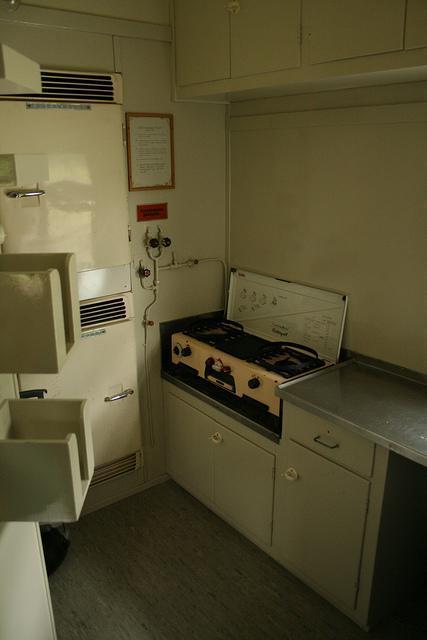How many bottles are on the shelf?
Give a very brief answer. 0. How many people are wearing a tie in the picture?
Give a very brief answer. 0. 